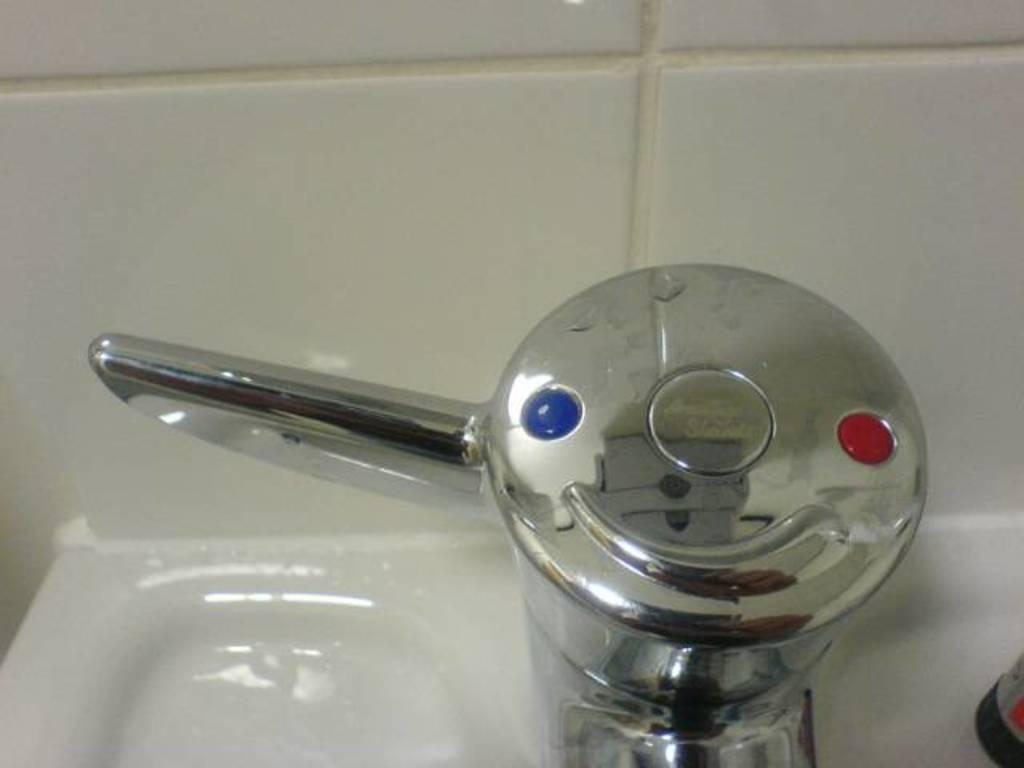What type of flooring is visible in the background of the image? There are tiles visible in the background of the image. What object has a reflection in the image? There is a reflection on a tap in the image. What part of a bathroom fixture is present in the image? A partial part of a wash basin is present in the image. Where is the sofa located in the image? There is no sofa present in the image. What type of care is being provided to the yard in the image? There is no yard present in the image. 